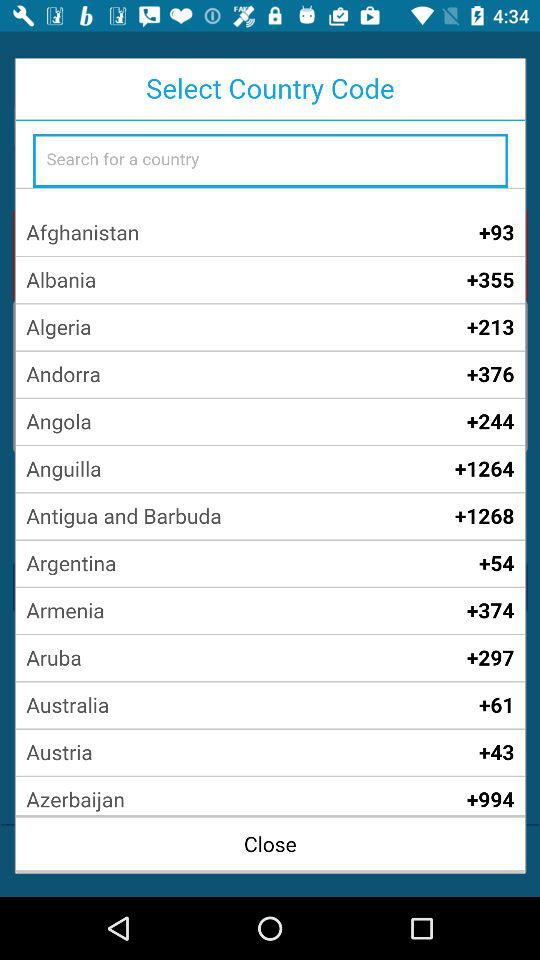What is the country code of Angola? The country code is +244. 